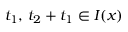Convert formula to latex. <formula><loc_0><loc_0><loc_500><loc_500>\, t _ { 1 } , \, t _ { 2 } + t _ { 1 } \in I ( x )</formula> 